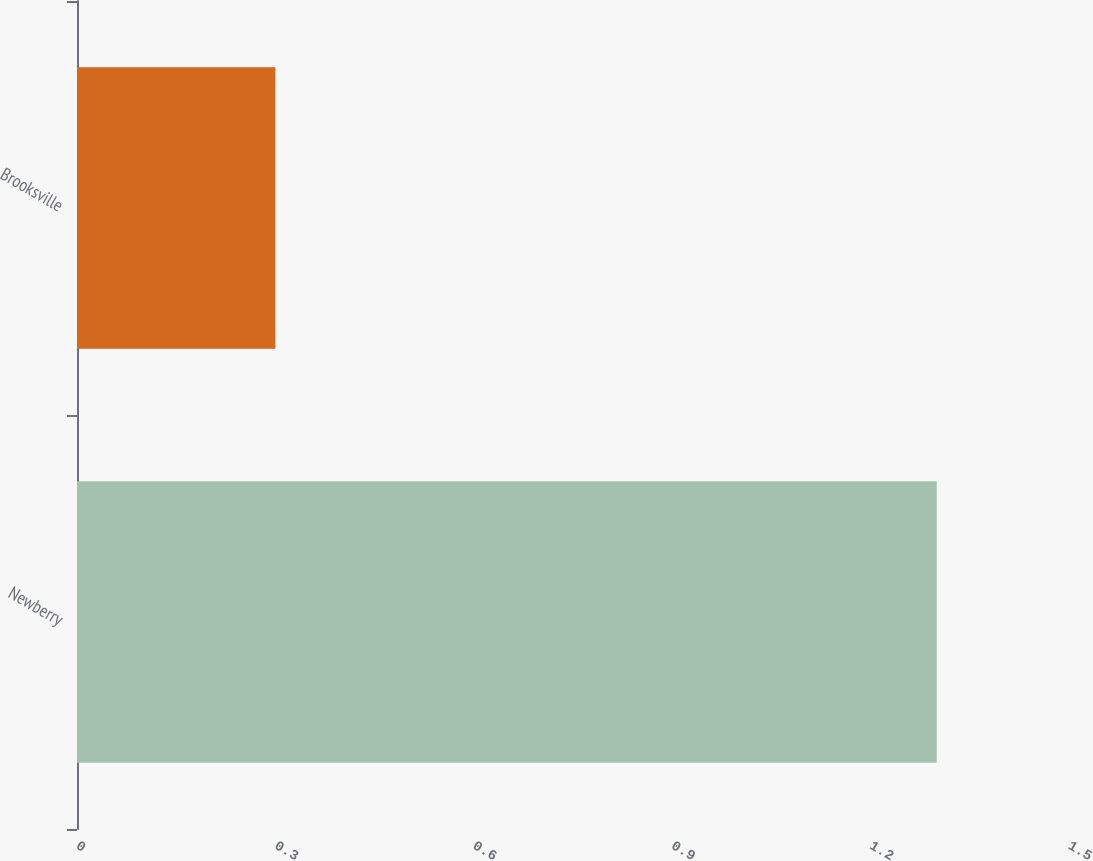<chart> <loc_0><loc_0><loc_500><loc_500><bar_chart><fcel>Newberry<fcel>Brooksville<nl><fcel>1.3<fcel>0.3<nl></chart> 